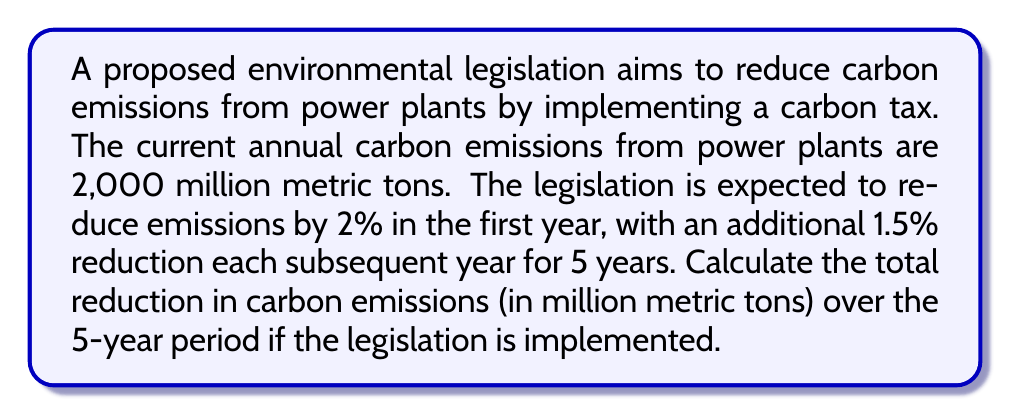Can you answer this question? Let's approach this step-by-step:

1) First, let's calculate the emissions reduction for each year:

   Year 1: $2,000 \times 0.02 = 40$ million metric tons
   Year 2: $2,000 \times (0.02 + 0.015) = 70$ million metric tons
   Year 3: $2,000 \times (0.02 + 0.015 \times 2) = 100$ million metric tons
   Year 4: $2,000 \times (0.02 + 0.015 \times 3) = 130$ million metric tons
   Year 5: $2,000 \times (0.02 + 0.015 \times 4) = 160$ million metric tons

2) Now, let's sum up these reductions:

   $$\text{Total Reduction} = 40 + 70 + 100 + 130 + 160 = 500$$

3) We can also express this mathematically:

   $$\text{Total Reduction} = 2,000 \times \sum_{i=1}^{5} (0.02 + 0.015(i-1))$$

   $$= 2,000 \times (0.02 \times 5 + 0.015 \times \frac{5 \times 4}{2})$$

   $$= 2,000 \times (0.1 + 0.15) = 2,000 \times 0.25 = 500$$

Therefore, the total reduction in carbon emissions over the 5-year period would be 500 million metric tons.
Answer: 500 million metric tons 